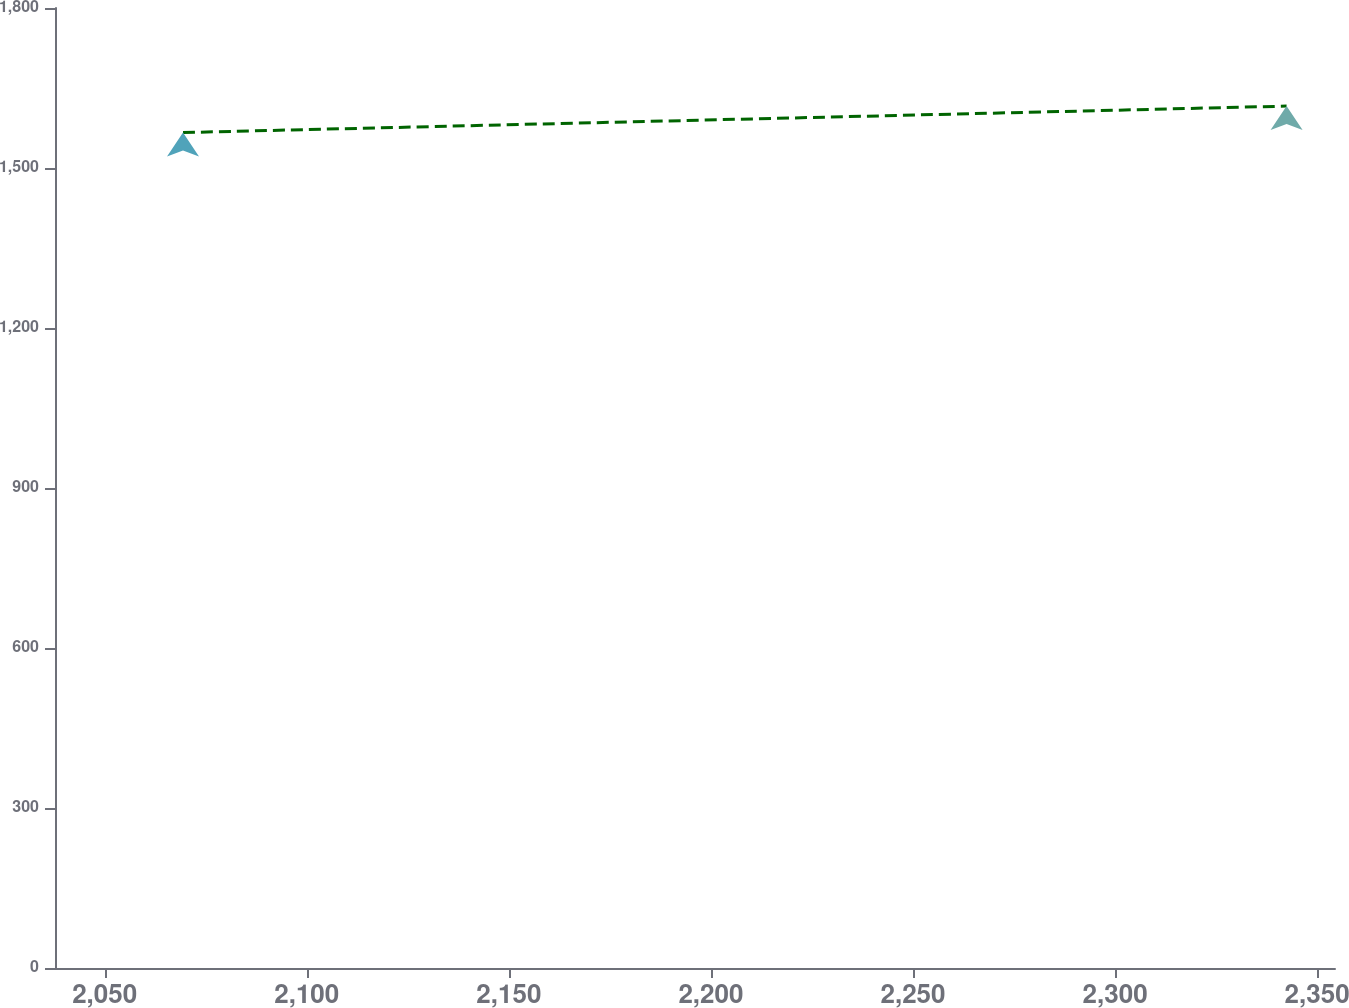Convert chart to OTSL. <chart><loc_0><loc_0><loc_500><loc_500><line_chart><ecel><fcel>Unnamed: 1<nl><fcel>2069.38<fcel>1566.46<nl><fcel>2342.44<fcel>1616.04<nl><fcel>2386.09<fcel>2062.27<nl></chart> 